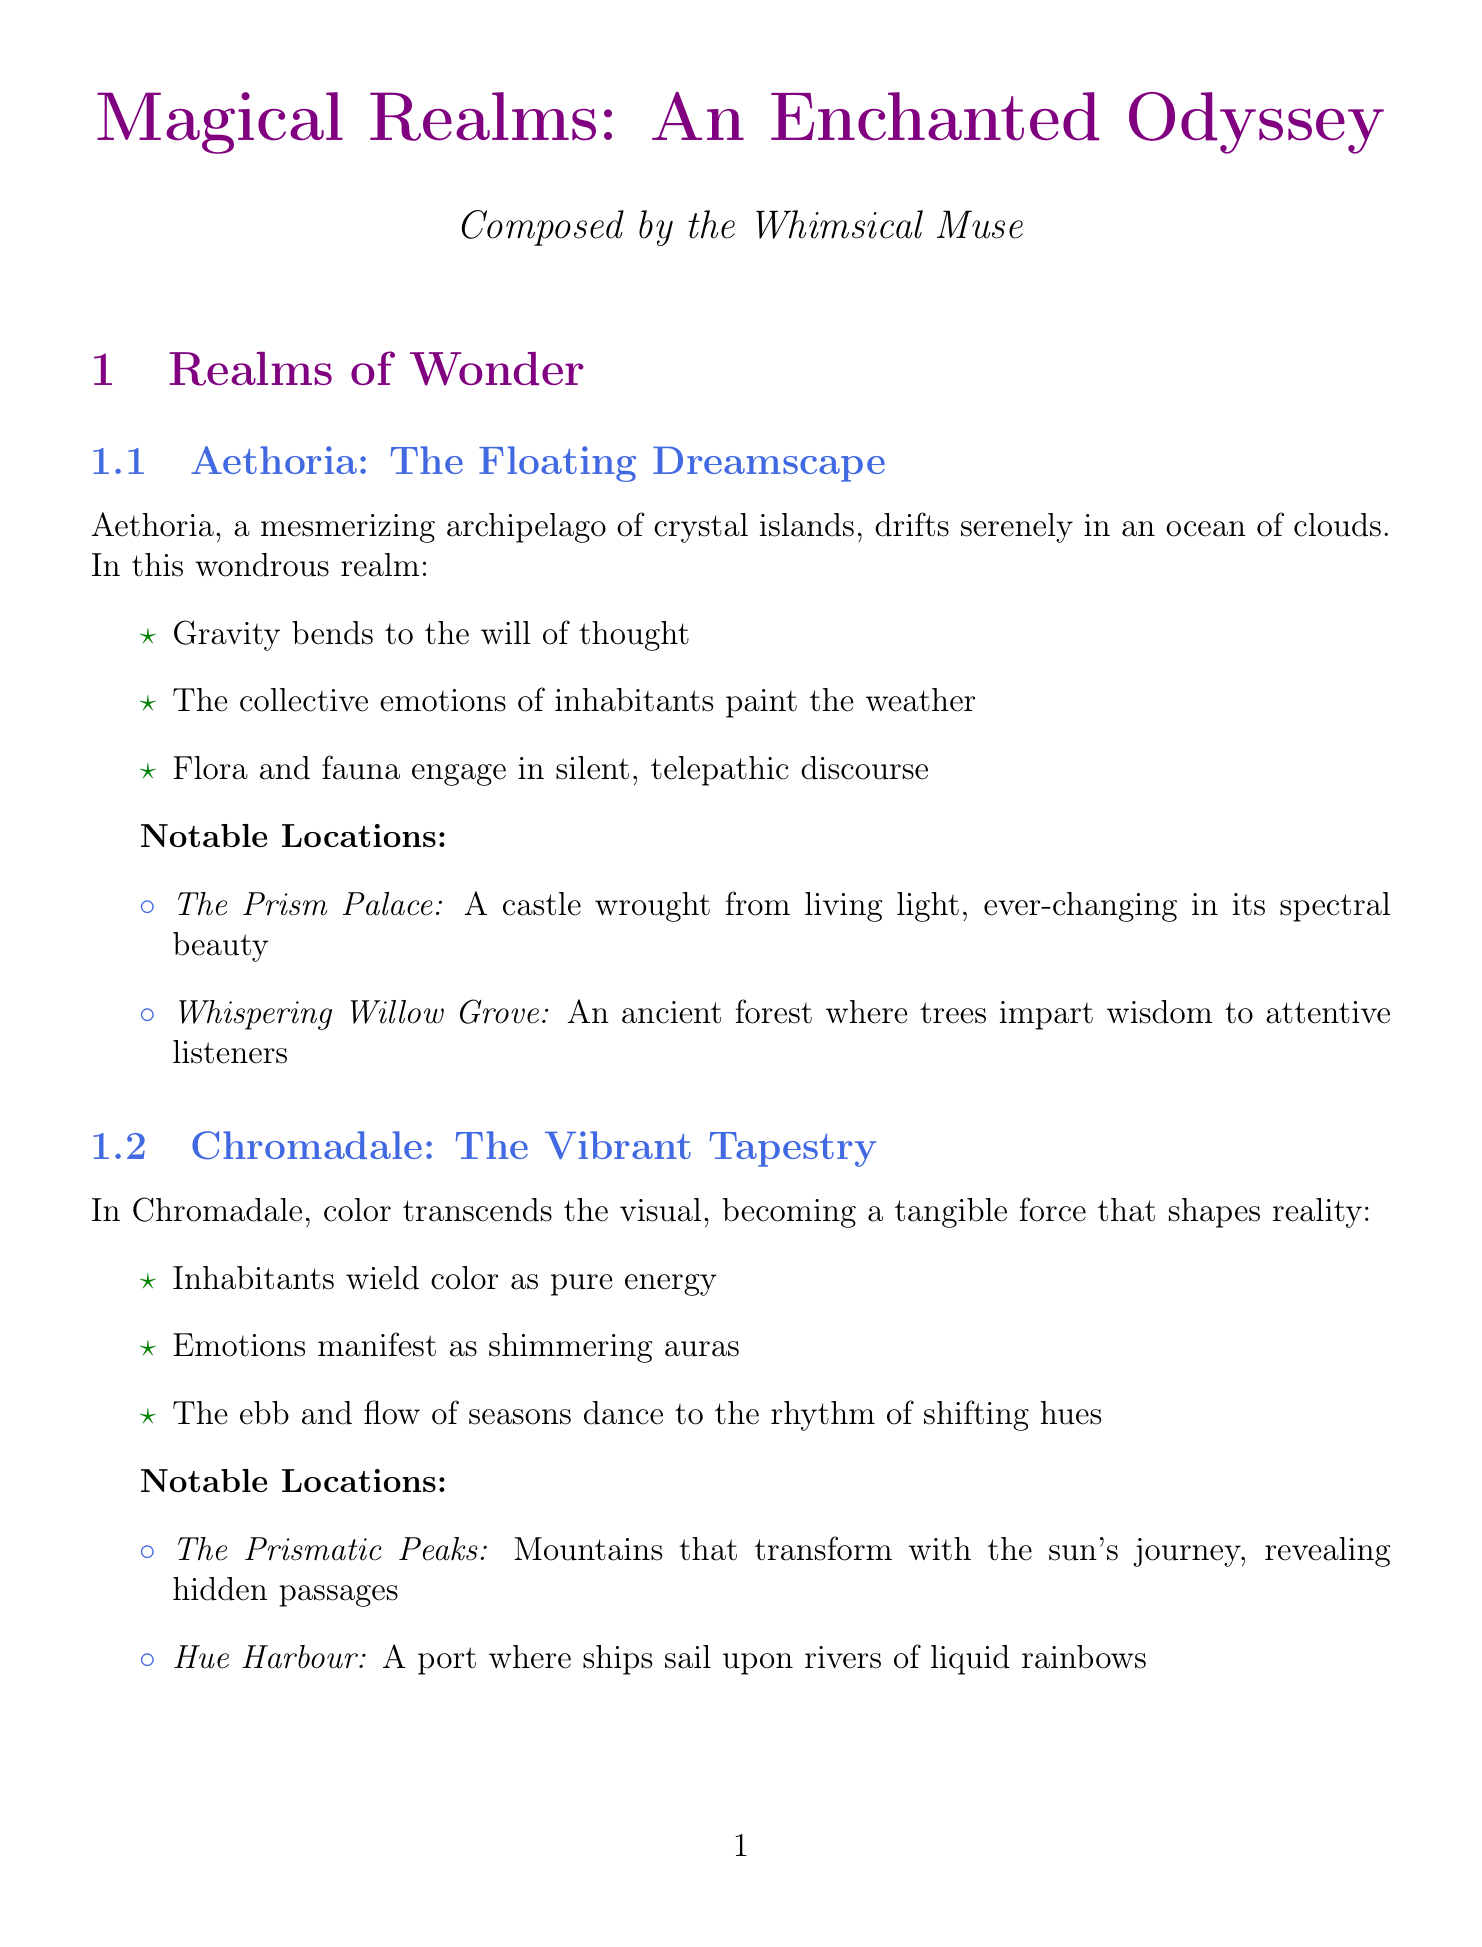What is the name of the floating archipelago? The name of the floating archipelago is Aethoria.
Answer: Aethoria What unique property allows flora and fauna to communicate? The unique property that allows flora and fauna to communicate is telepathically.
Answer: Telepathically How many notable locations are listed for Chromadale? There are two notable locations listed for Chromadale.
Answer: Two What is the habitat of the Echobats? The habitat of the Echobats is the Resonant Caverns.
Answer: Resonant Caverns Which artifact allows the user to step into stories? The artifact that allows the user to step into stories is the Ethereal Quill.
Answer: Ethereal Quill What is the primary form of magic in Echovia? The primary form of magic in Echovia is music.
Answer: Music What do travelers in Aethoria need to think to maintain buoyancy? Travelers in Aethoria need to think 'light' thoughts to maintain buoyancy.
Answer: 'Light' thoughts How do the seasons change in Chromadale? The seasons change based on dominant colors in the environment.
Answer: Dominant colors in the environment What color is associated with the section titles in the document? The color associated with the section titles is magicpurple.
Answer: Magicpurple 